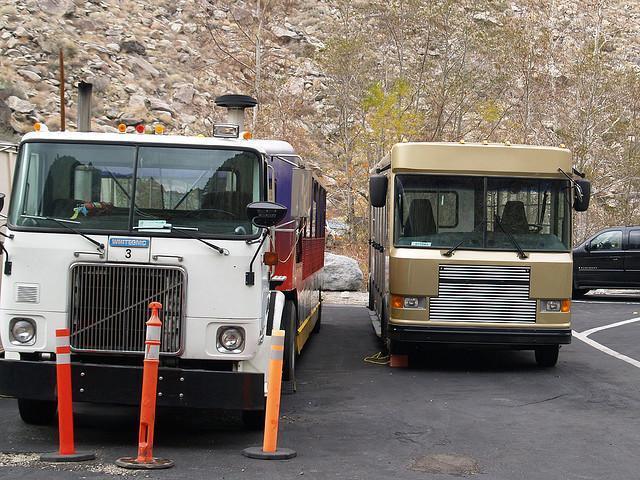How many traffic cones are there?
Give a very brief answer. 3. How many trucks can you see?
Give a very brief answer. 2. 